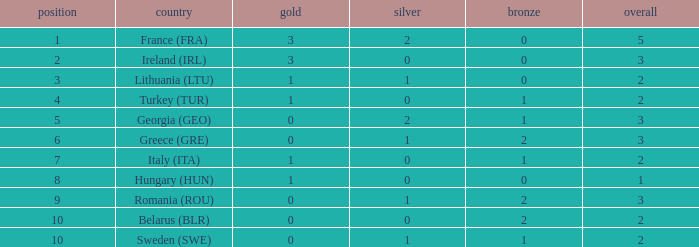I'm looking to parse the entire table for insights. Could you assist me with that? {'header': ['position', 'country', 'gold', 'silver', 'bronze', 'overall'], 'rows': [['1', 'France (FRA)', '3', '2', '0', '5'], ['2', 'Ireland (IRL)', '3', '0', '0', '3'], ['3', 'Lithuania (LTU)', '1', '1', '0', '2'], ['4', 'Turkey (TUR)', '1', '0', '1', '2'], ['5', 'Georgia (GEO)', '0', '2', '1', '3'], ['6', 'Greece (GRE)', '0', '1', '2', '3'], ['7', 'Italy (ITA)', '1', '0', '1', '2'], ['8', 'Hungary (HUN)', '1', '0', '0', '1'], ['9', 'Romania (ROU)', '0', '1', '2', '3'], ['10', 'Belarus (BLR)', '0', '0', '2', '2'], ['10', 'Sweden (SWE)', '0', '1', '1', '2']]} What's the total of Sweden (SWE) having less than 1 silver? None. 